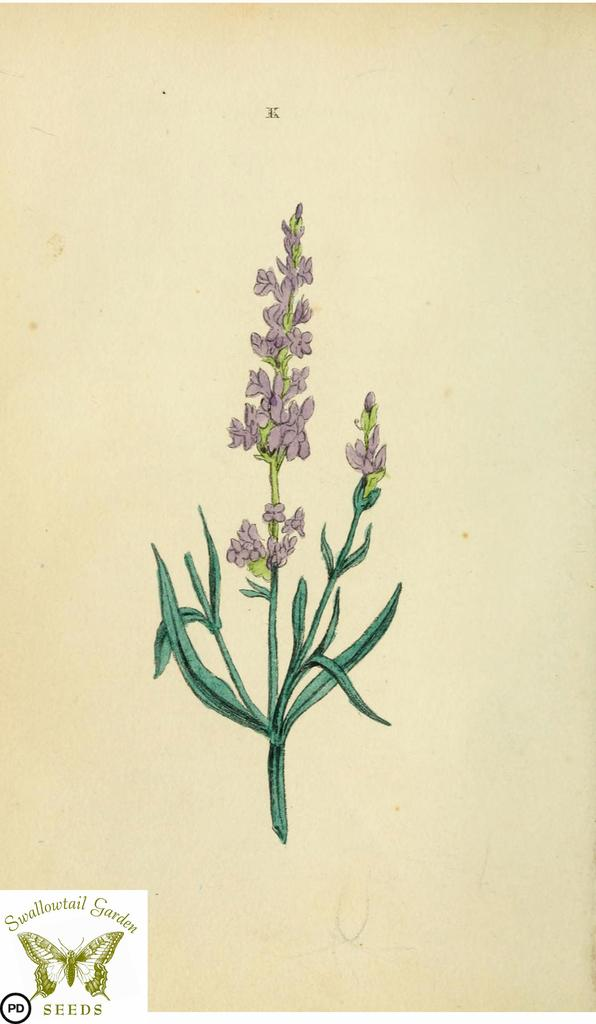What is depicted in the painting in the image? There is a painting of a flower with leaves in the image. What can be found in the bottom left corner of the image? There is a logo and text in the bottom left corner of the image. How many brothers does the boy in the image have? There is no boy present in the image, so it is not possible to determine the number of brothers he might have. 